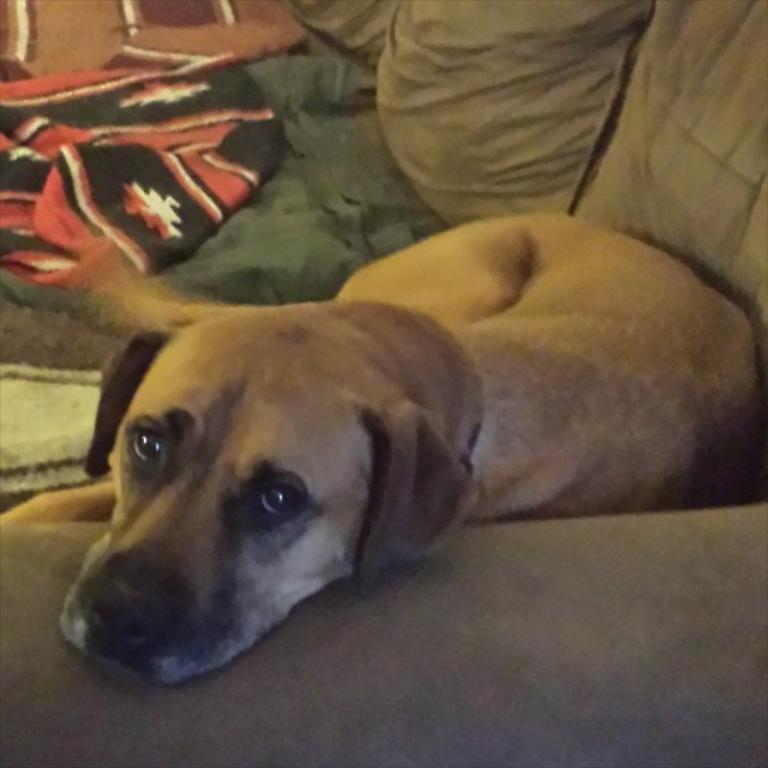What type of animal is in the image? There is a dog in the image. Where is the dog located? The dog is on a couch. What else is on the couch besides the dog? There are clothes on the couch. What type of canvas is the dog sitting on in the image? There is no canvas present in the image; the dog is sitting on a couch. 